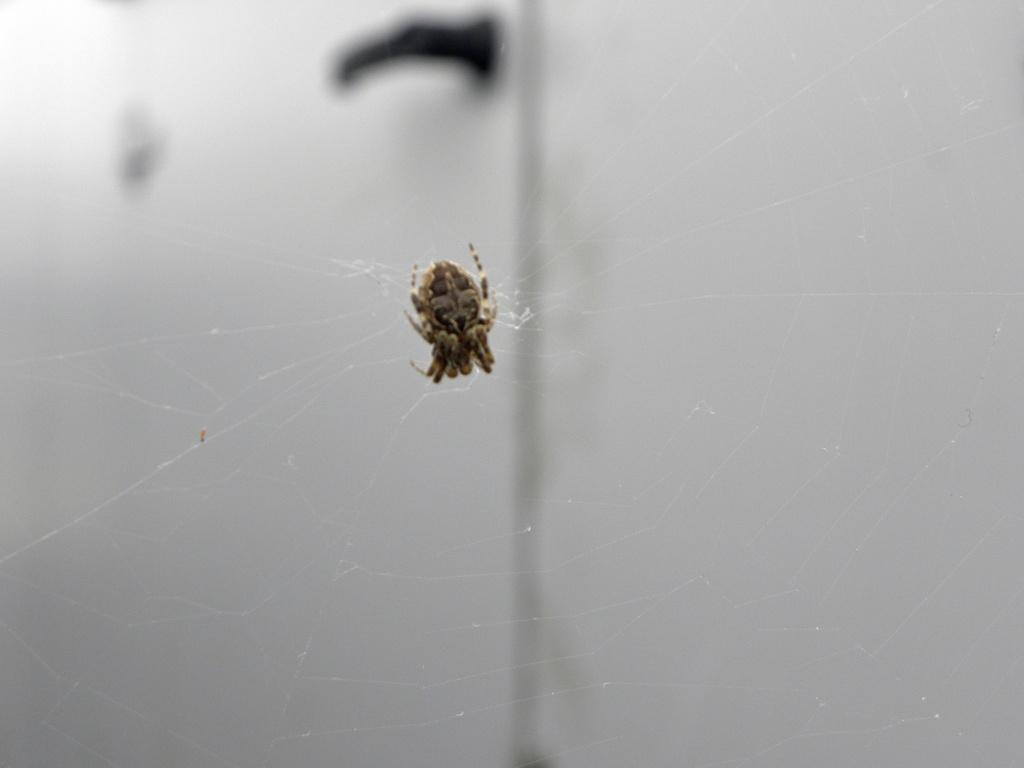What is the main subject of the image? There is a spider in the image. What is associated with the spider in the image? There is a spider web in the image. Can you describe the background of the image? The background of the image is blurry. What object can be seen in the background of the image? There is a door handle visible in the background of the image. What type of whip is the spider using to create the web in the image? There is no whip present in the image; spiders create webs using their silk-producing organs called spinnerets. What is the name of the spider in the image? The provided facts do not give any information about the name of the spider in the image. 